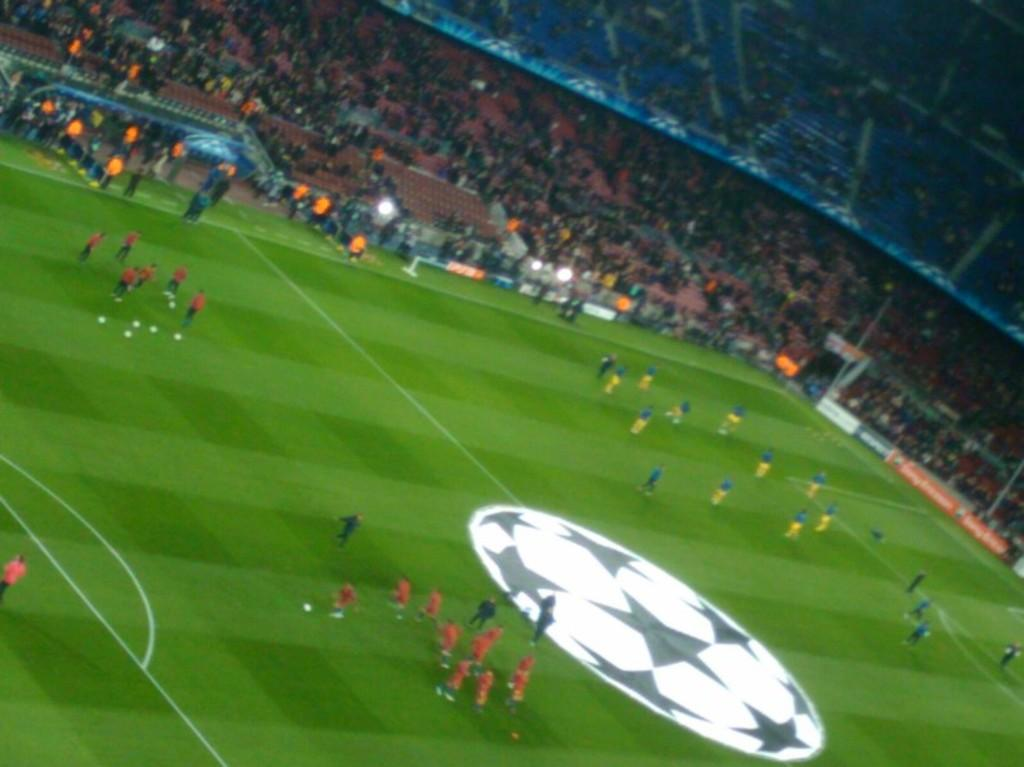What type of sports facility is depicted in the image? The image shows a football ground. What is happening on the football ground? There are players on the football ground. Can you describe the people watching the game? There is an audience in the image, and they are sitting on chairs. How are the audience members feeling about the game? The audience is enjoying the game. What type of bean is being used to film the game in the image? There is no bean present in the image, nor is there any indication that the game is being filmed. 